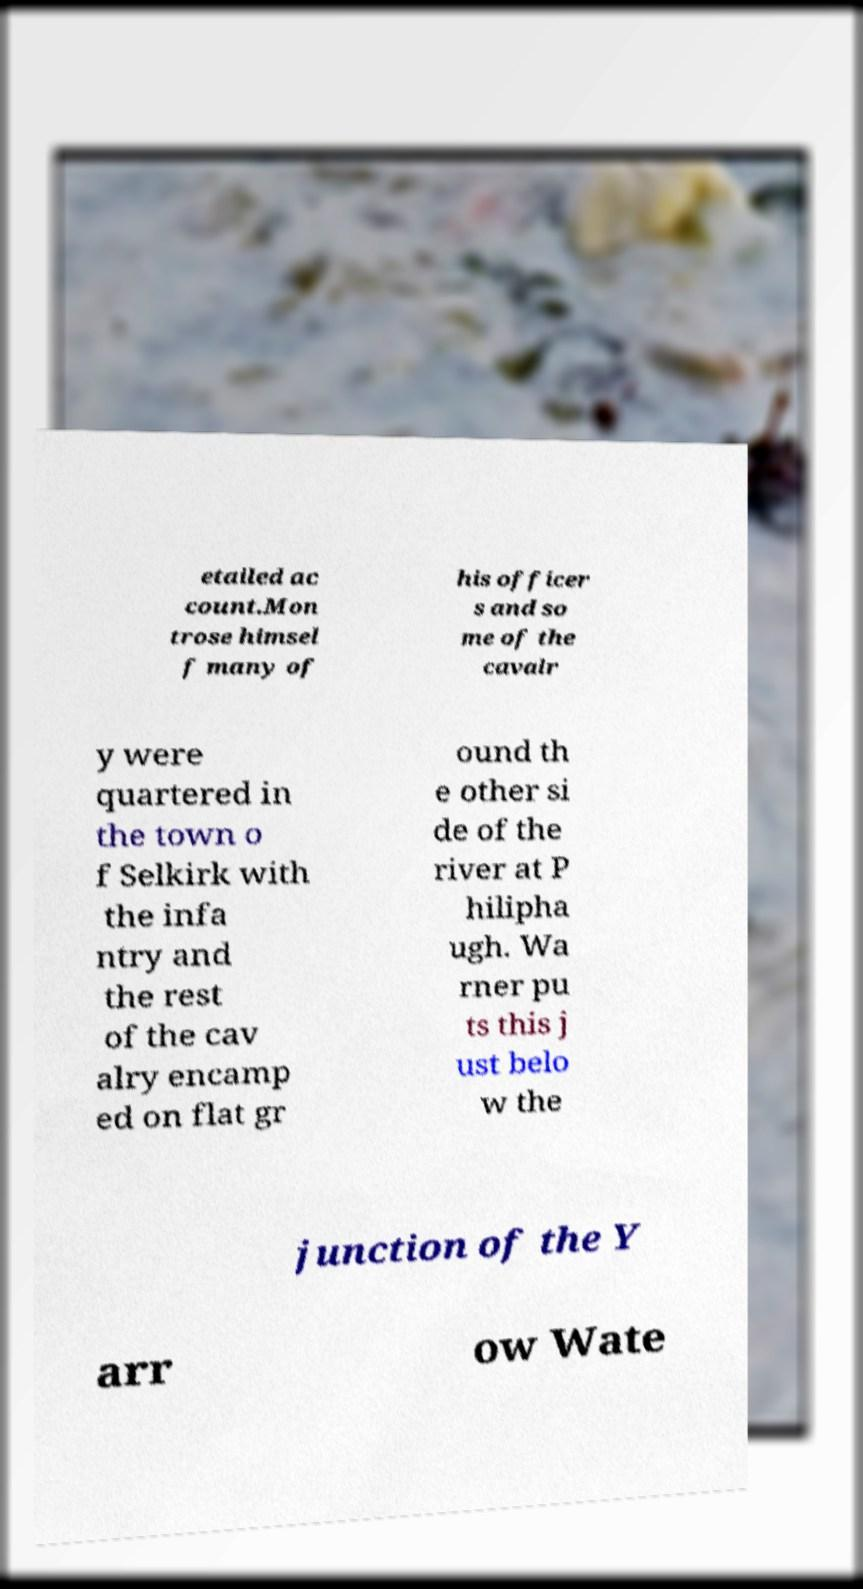I need the written content from this picture converted into text. Can you do that? etailed ac count.Mon trose himsel f many of his officer s and so me of the cavalr y were quartered in the town o f Selkirk with the infa ntry and the rest of the cav alry encamp ed on flat gr ound th e other si de of the river at P hilipha ugh. Wa rner pu ts this j ust belo w the junction of the Y arr ow Wate 